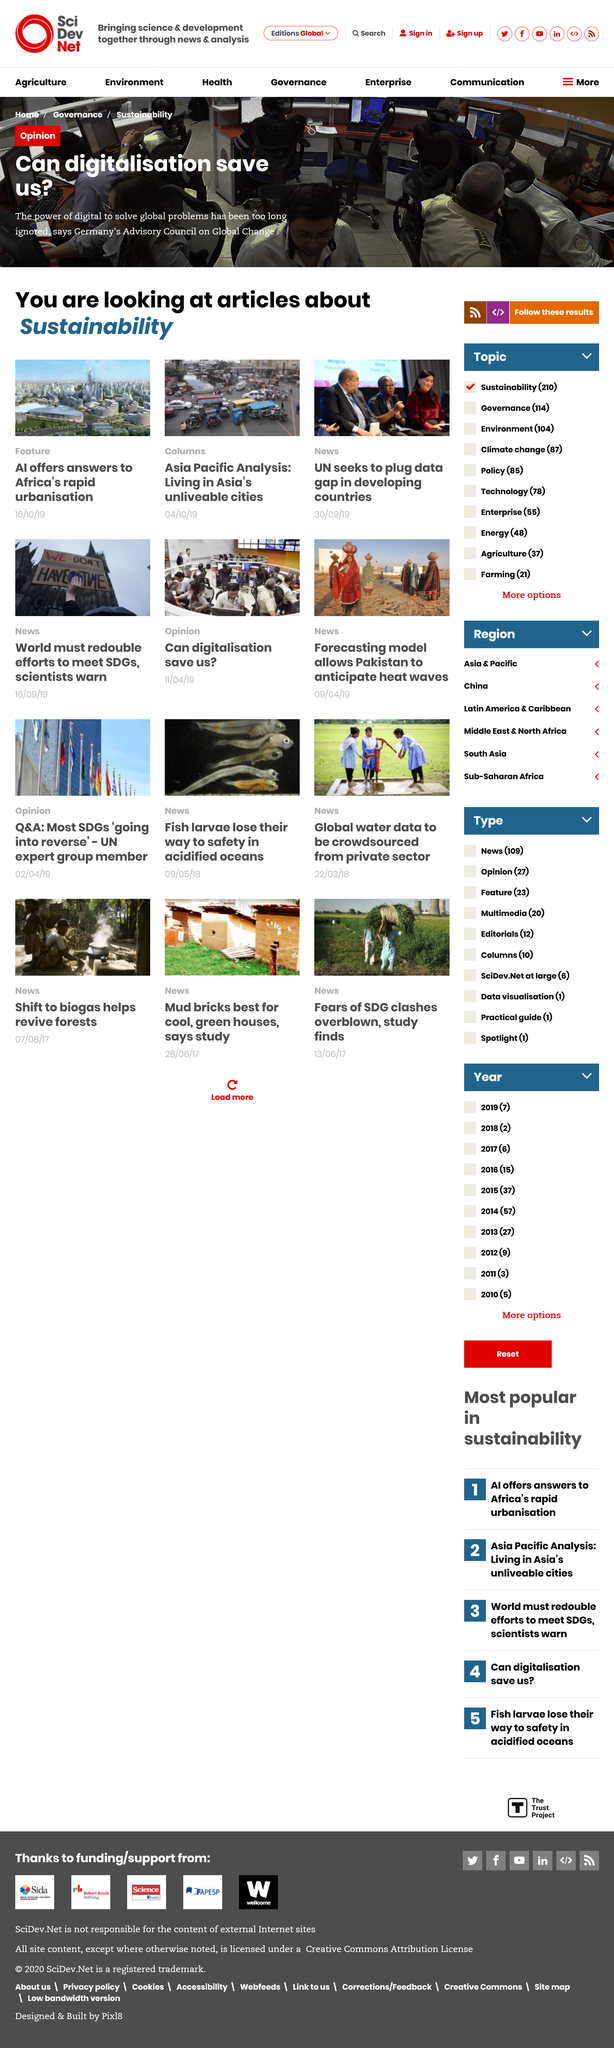Highlight a few significant elements in this photo. The image mentions several articles that are related to sustainability. The development of AI is addressing the rapid urbanization in Africa by providing answers and solutions to the challenges faced by cities. The United Nations aims to address the data gap in developing countries by providing necessary resources and support to enhance their statistical capabilities. 